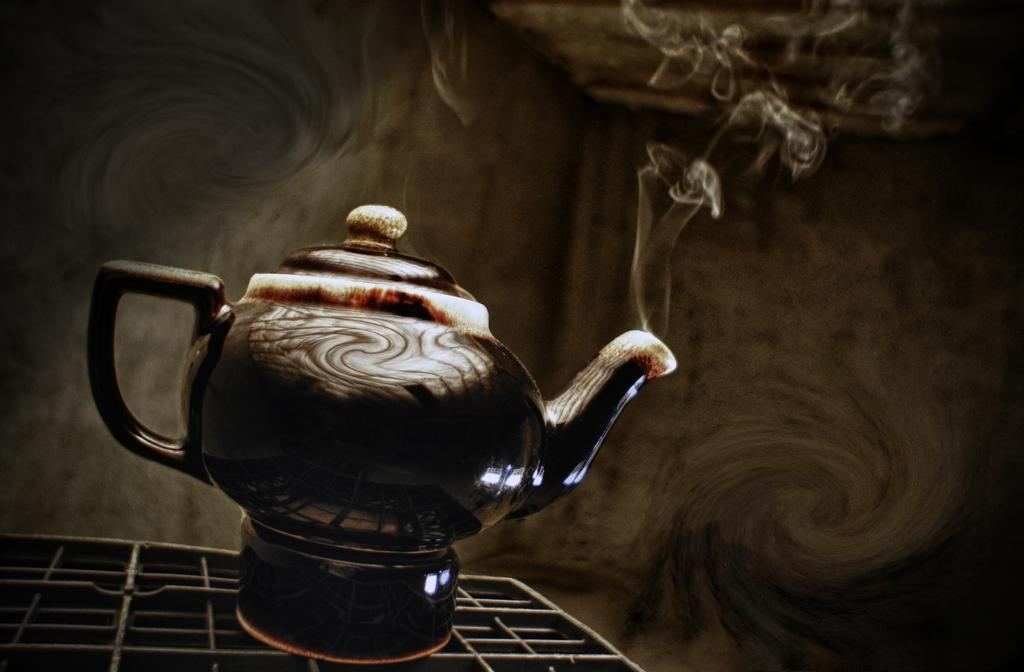What is the main object in the image? There is a tea kettle in the image. Where is the tea kettle located? The tea kettle is on a grill. What is happening to the tea kettle? Smoke is coming out of the tea kettle. Can you describe the background of the image? The background of the image is blurry. What type of pie is being served through the window in the image? There is no pie or window present in the image; it features a tea kettle on a grill with smoke coming out of it. What type of badge is the person wearing in the image? There is no person or badge present in the image. 